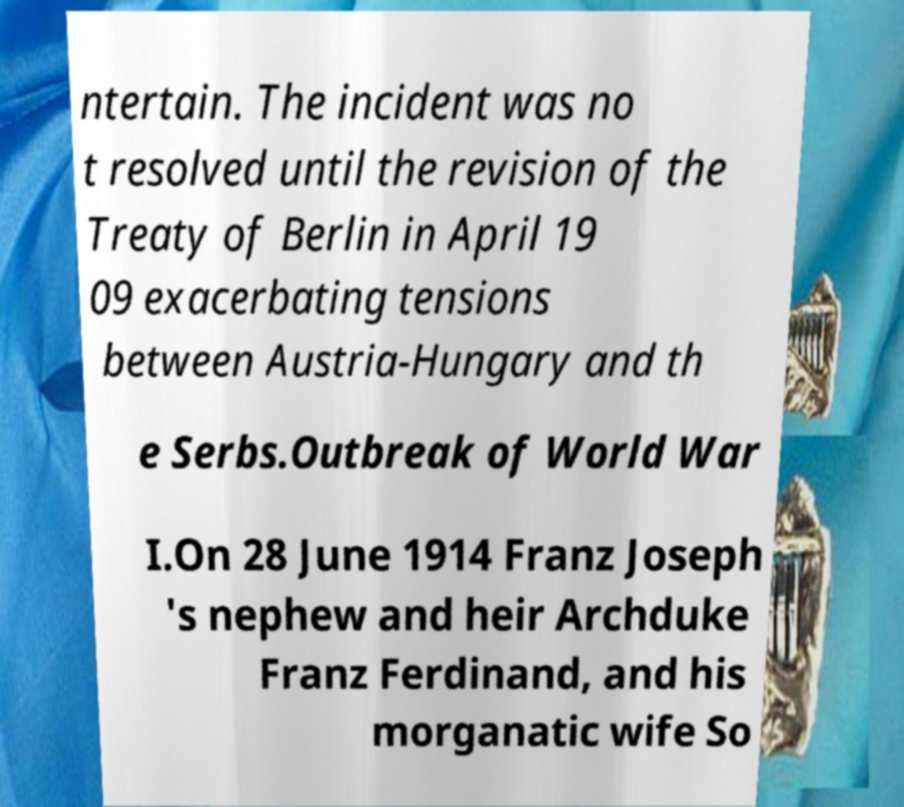Could you extract and type out the text from this image? ntertain. The incident was no t resolved until the revision of the Treaty of Berlin in April 19 09 exacerbating tensions between Austria-Hungary and th e Serbs.Outbreak of World War I.On 28 June 1914 Franz Joseph 's nephew and heir Archduke Franz Ferdinand, and his morganatic wife So 